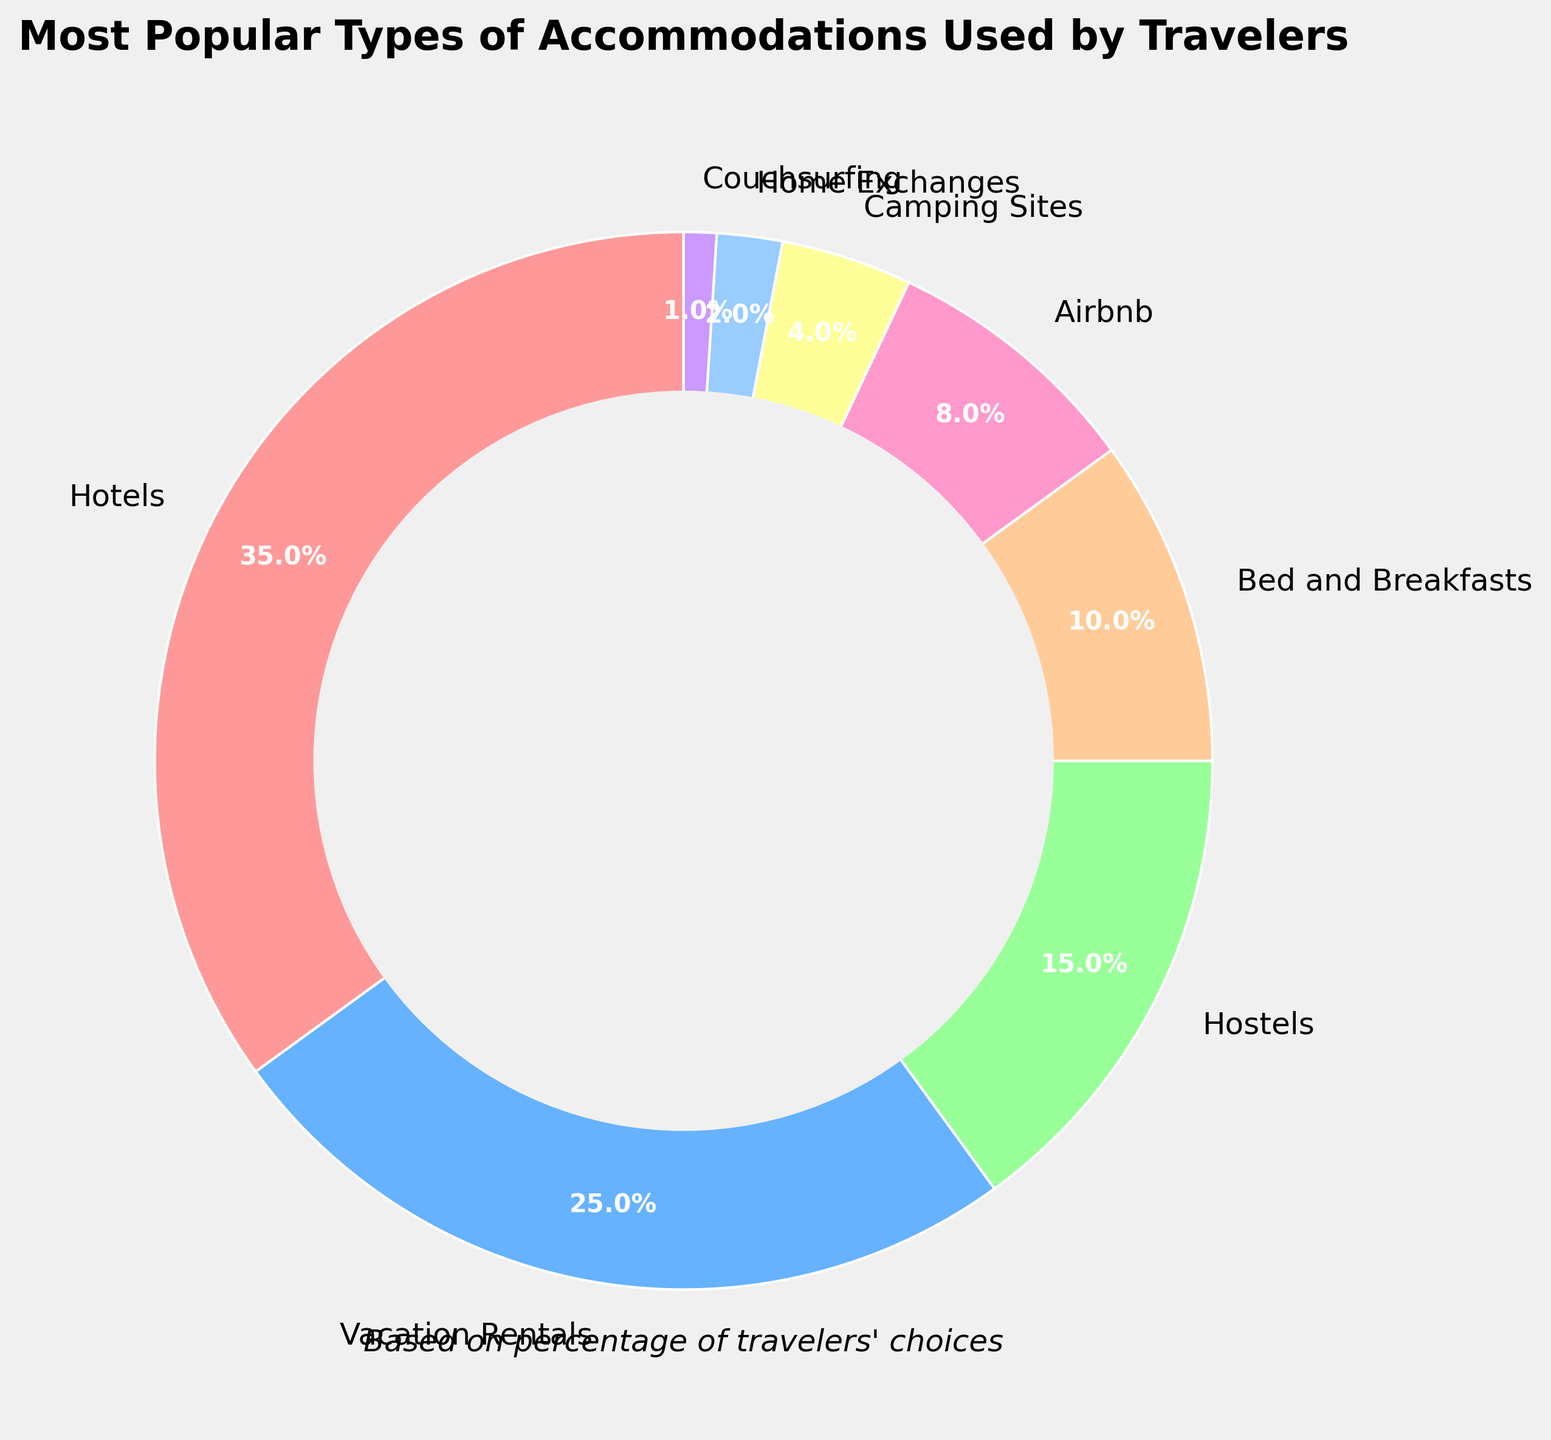What's the most popular type of accommodation among travelers? The largest slice in the pie chart corresponds to Hotels with 35%. This is the highest percentage among the given categories.
Answer: Hotels Which type of accommodation is more popular: Hostels or Airbnb? From the pie chart, Hostels have 15% whereas Airbnb has 8%. Since 15% is greater than 8%, Hostels are more popular.
Answer: Hostels If we combine the percentages of Vacation Rentals and Bed and Breakfasts, what is the total percentage? The percentage for Vacation Rentals is 25% and for Bed and Breakfasts is 10%. Adding them together gives 25% + 10% = 35%.
Answer: 35% How many categories of accommodations have percentages less than 5%? The pie chart indicates that Camping Sites (4%), Home Exchanges (2%), and Couchsurfing (1%) are less than 5%. There are three such categories.
Answer: 3 Which category represents the smallest percentage of traveler accommodations? The smallest slice in the pie chart corresponds to Couchsurfing, which has a percentage of 1%.
Answer: Couchsurfing Compare the total percentage of Hotels and Hostels with the total percentage of Camping Sites, Home Exchanges, and Couchsurfing. Which group has a higher percentage? Hotels and Hostels together have 35% + 15% = 50%. Camping Sites, Home Exchanges, and Couchsurfing together have 4% + 2% + 1% = 7%. Comparing 50% and 7%, Hotels and Hostels have a higher percentage.
Answer: Hotels and Hostels What percentage of accommodations are represented by non-hotel options? Adding the percentages of all non-hotel accommodations (Vacation Rentals, Hostels, Bed and Breakfasts, Airbnb, Camping Sites, Home Exchanges, Couchsurfing) gives 25% + 15% + 10% + 8% + 4% + 2% + 1% = 65%.
Answer: 65% Which is larger: the percentage of Bed and Breakfasts or the combined percentage of Home Exchanges and Couchsurfing? The percentage of Bed and Breakfasts is 10%. The combined percentage of Home Exchanges (2%) and Couchsurfing (1%) is 2% + 1% = 3%. Since 10% is greater than 3%, Bed and Breakfasts is larger.
Answer: Bed and Breakfasts By what percentage does the popularity of Hotels exceed that of Vacation Rentals? The percentage of Hotels is 35%, and that of Vacation Rentals is 25%. The difference is 35% - 25% = 10%.
Answer: 10% 